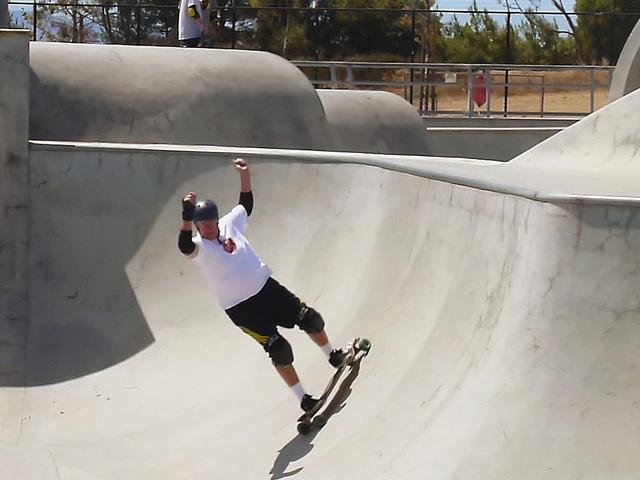What is this place?
Quick response, please. Skate park. Is the guy proud of his performance?
Be succinct. Yes. What color is his shirt?
Be succinct. White. 